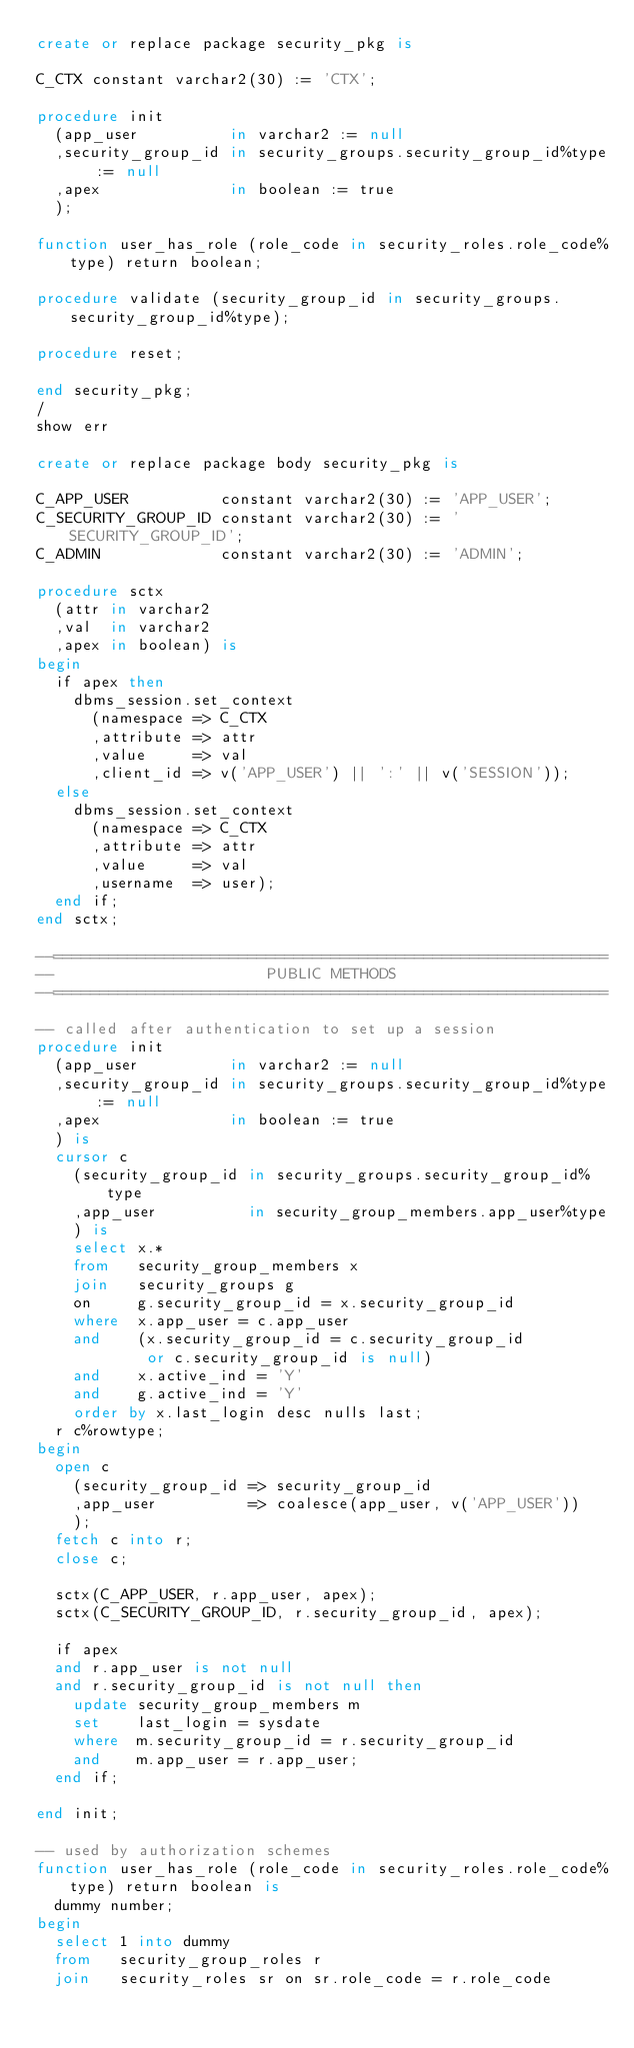<code> <loc_0><loc_0><loc_500><loc_500><_SQL_>create or replace package security_pkg is

C_CTX constant varchar2(30) := 'CTX';

procedure init
  (app_user          in varchar2 := null
  ,security_group_id in security_groups.security_group_id%type := null
  ,apex              in boolean := true
  );

function user_has_role (role_code in security_roles.role_code%type) return boolean;

procedure validate (security_group_id in security_groups.security_group_id%type);

procedure reset;

end security_pkg;
/
show err

create or replace package body security_pkg is

C_APP_USER          constant varchar2(30) := 'APP_USER';
C_SECURITY_GROUP_ID constant varchar2(30) := 'SECURITY_GROUP_ID';
C_ADMIN             constant varchar2(30) := 'ADMIN';

procedure sctx
  (attr in varchar2
  ,val  in varchar2
  ,apex in boolean) is
begin
  if apex then
    dbms_session.set_context
      (namespace => C_CTX
      ,attribute => attr
      ,value     => val
      ,client_id => v('APP_USER') || ':' || v('SESSION'));
  else
    dbms_session.set_context
      (namespace => C_CTX
      ,attribute => attr
      ,value     => val
      ,username  => user);
  end if;
end sctx;

--============================================================
--                       PUBLIC METHODS
--============================================================

-- called after authentication to set up a session
procedure init
  (app_user          in varchar2 := null
  ,security_group_id in security_groups.security_group_id%type := null
  ,apex              in boolean := true
  ) is
  cursor c
    (security_group_id in security_groups.security_group_id%type
    ,app_user          in security_group_members.app_user%type
    ) is
    select x.*
    from   security_group_members x
    join   security_groups g
    on     g.security_group_id = x.security_group_id
    where  x.app_user = c.app_user
    and    (x.security_group_id = c.security_group_id
            or c.security_group_id is null)
    and    x.active_ind = 'Y'
    and    g.active_ind = 'Y'
    order by x.last_login desc nulls last;
  r c%rowtype;
begin
  open c
    (security_group_id => security_group_id
    ,app_user          => coalesce(app_user, v('APP_USER'))
    );
  fetch c into r;
  close c;

  sctx(C_APP_USER, r.app_user, apex);
  sctx(C_SECURITY_GROUP_ID, r.security_group_id, apex);

  if apex
  and r.app_user is not null
  and r.security_group_id is not null then
    update security_group_members m
    set    last_login = sysdate
    where  m.security_group_id = r.security_group_id
    and    m.app_user = r.app_user;
  end if;

end init;

-- used by authorization schemes
function user_has_role (role_code in security_roles.role_code%type) return boolean is
  dummy number;
begin
  select 1 into dummy
  from   security_group_roles r
  join   security_roles sr on sr.role_code = r.role_code</code> 